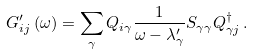Convert formula to latex. <formula><loc_0><loc_0><loc_500><loc_500>G ^ { \prime } _ { i j } \left ( \omega \right ) = \sum _ { \gamma } Q _ { i \gamma } \frac { 1 } { \omega - \lambda _ { \gamma } ^ { \prime } } S _ { \gamma \gamma } Q _ { \gamma j } ^ { \dagger } \, .</formula> 